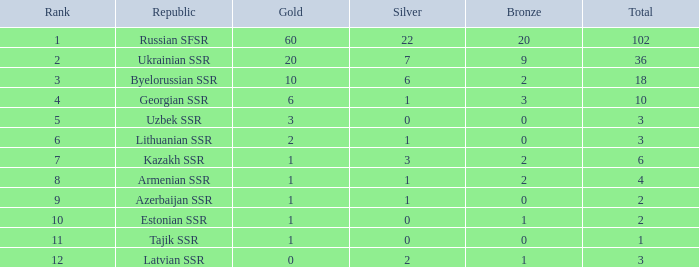How many silver medals do teams with a rank higher than 3 and a total score of less than 2 hold? 0.0. 